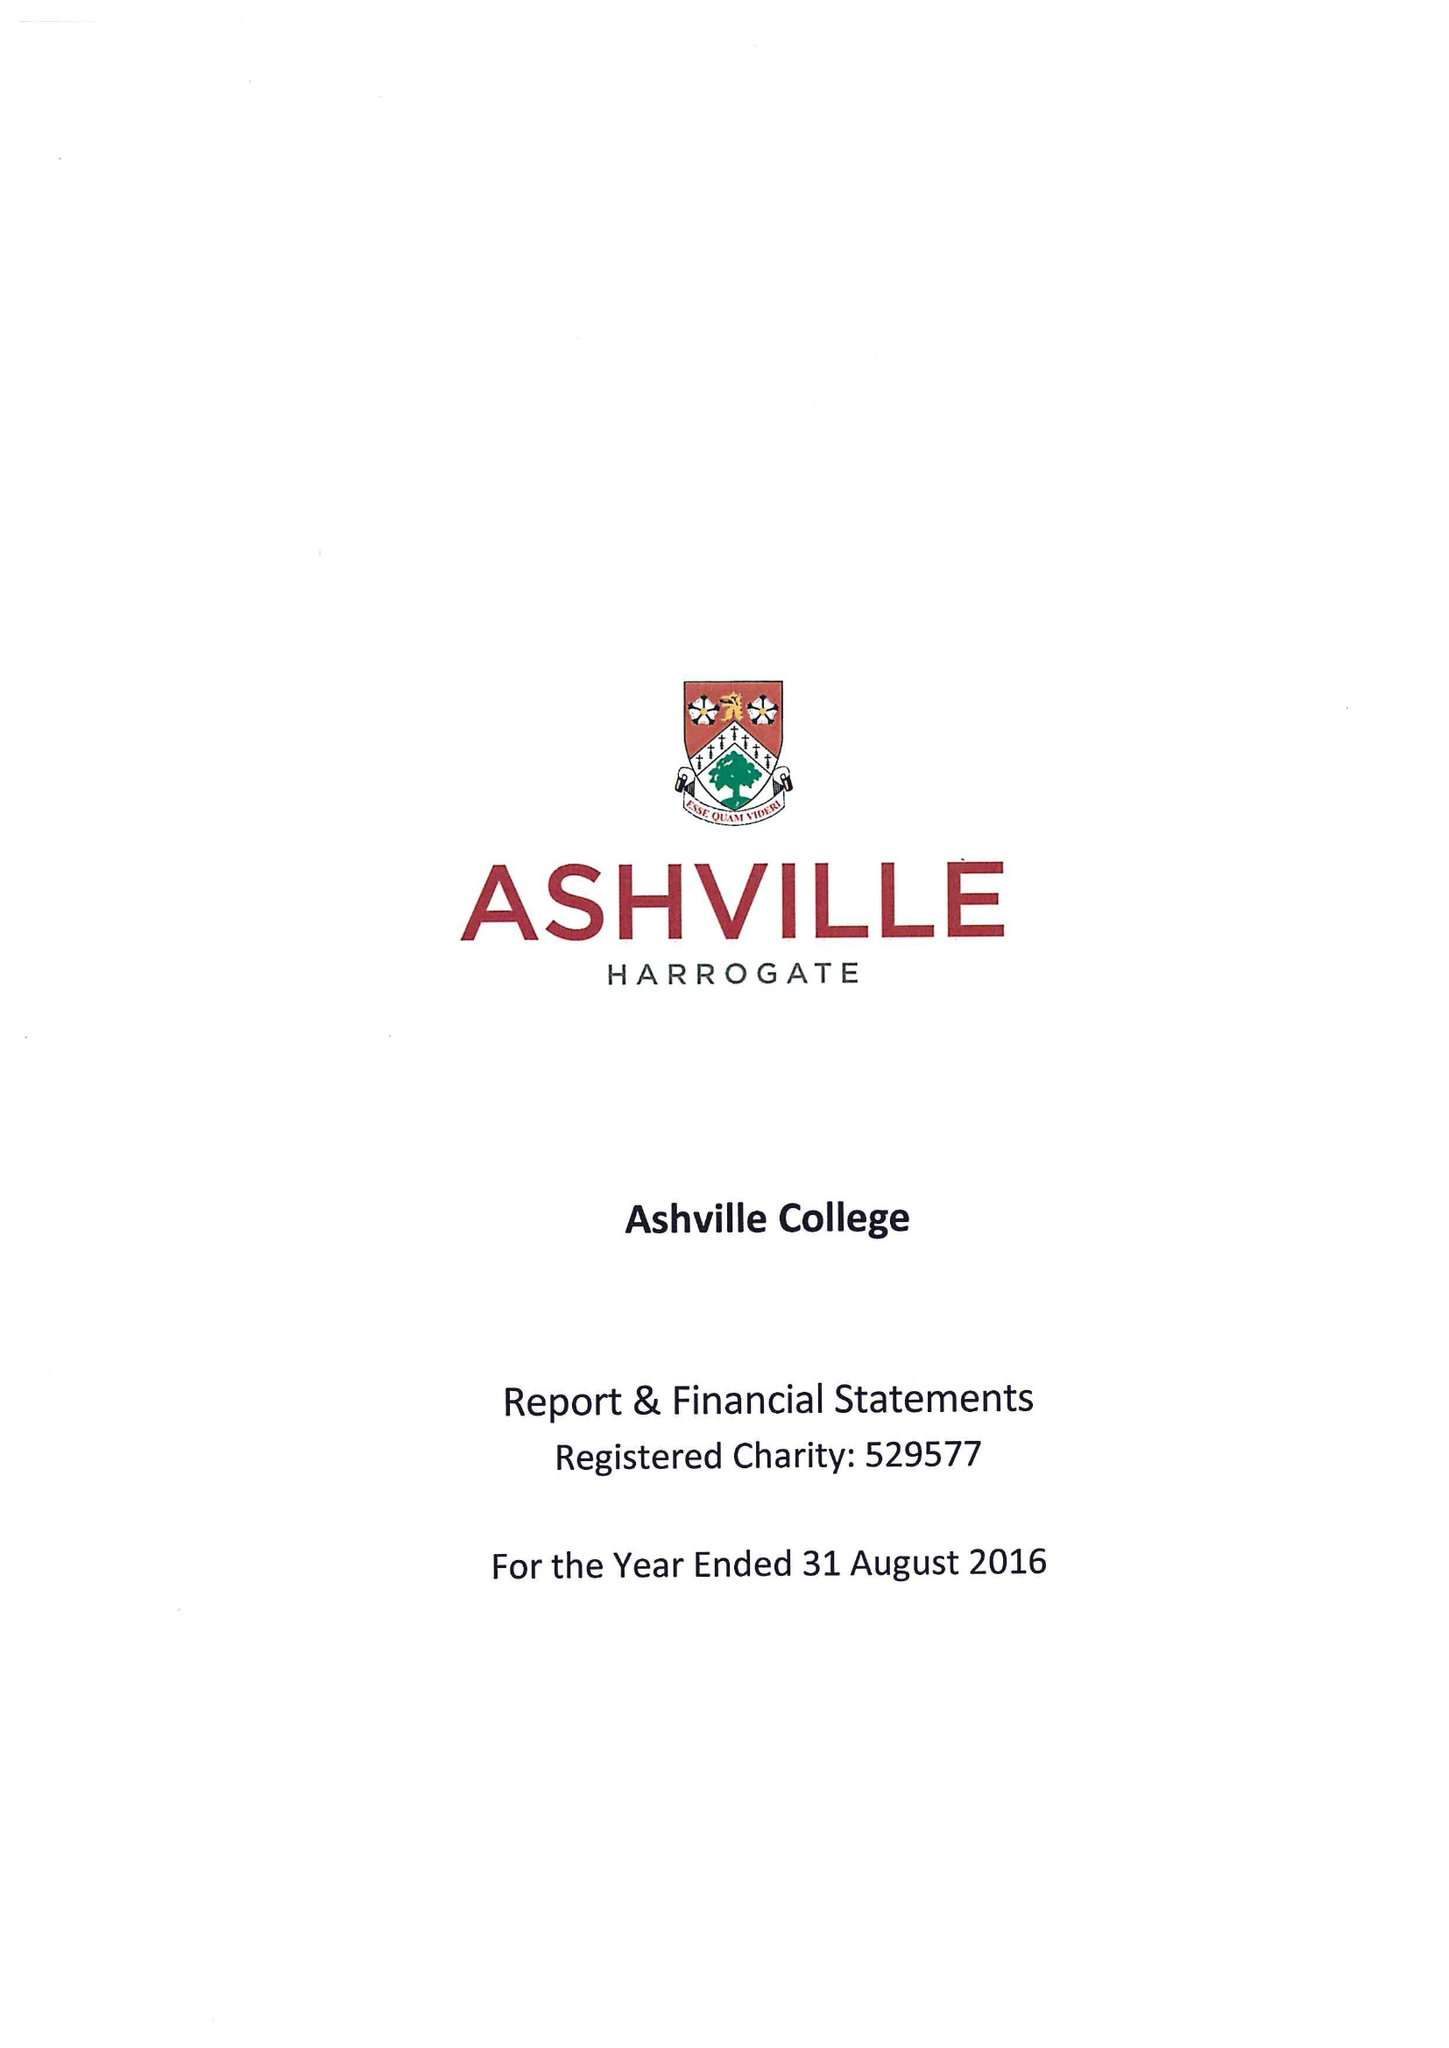What is the value for the address__post_town?
Answer the question using a single word or phrase. HARROGATE 